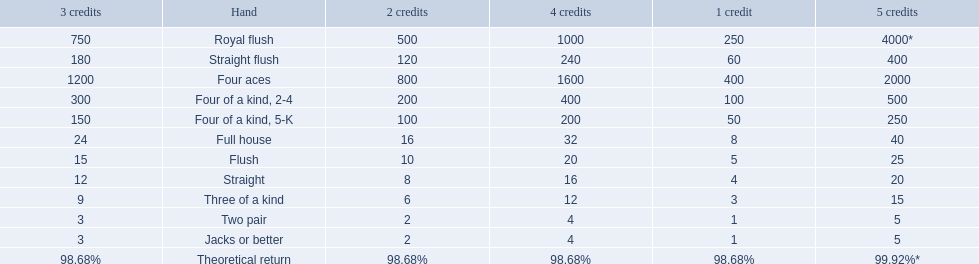Which hand is the third best hand in the card game super aces? Four aces. Which hand is the second best hand? Straight flush. Which hand had is the best hand? Royal flush. 